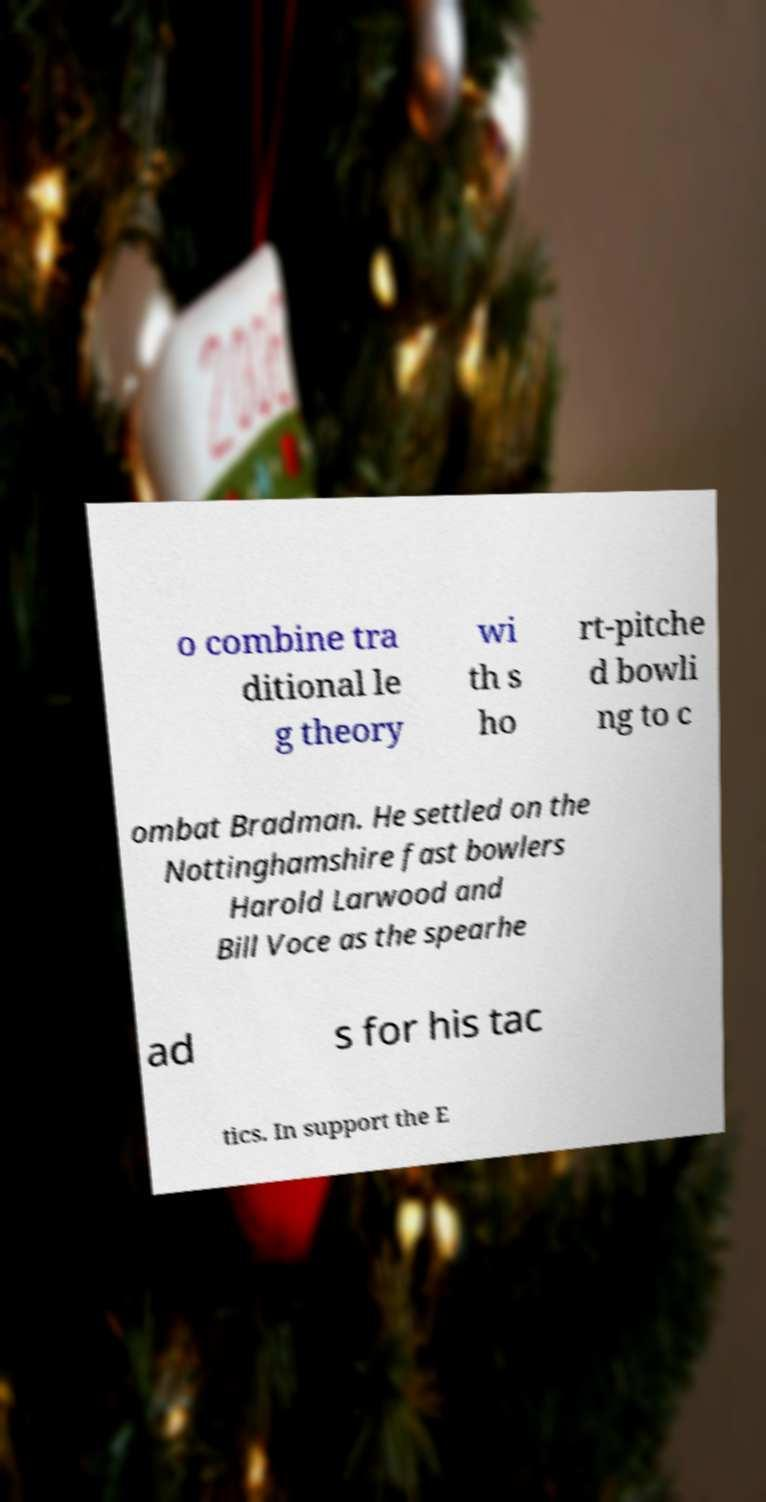Please read and relay the text visible in this image. What does it say? o combine tra ditional le g theory wi th s ho rt-pitche d bowli ng to c ombat Bradman. He settled on the Nottinghamshire fast bowlers Harold Larwood and Bill Voce as the spearhe ad s for his tac tics. In support the E 